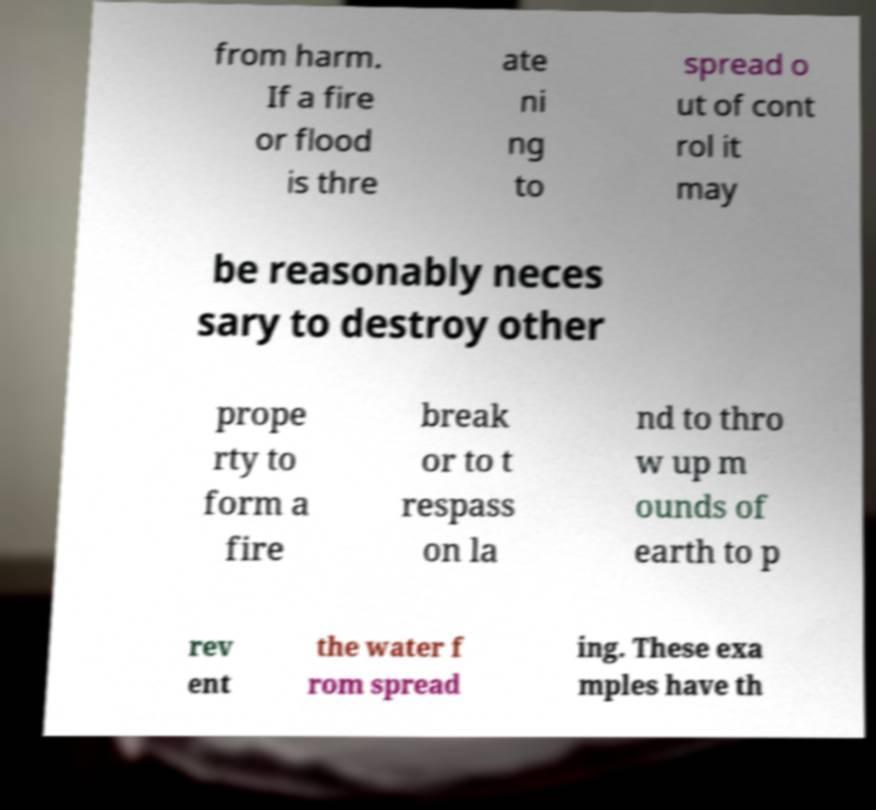Please read and relay the text visible in this image. What does it say? from harm. If a fire or flood is thre ate ni ng to spread o ut of cont rol it may be reasonably neces sary to destroy other prope rty to form a fire break or to t respass on la nd to thro w up m ounds of earth to p rev ent the water f rom spread ing. These exa mples have th 